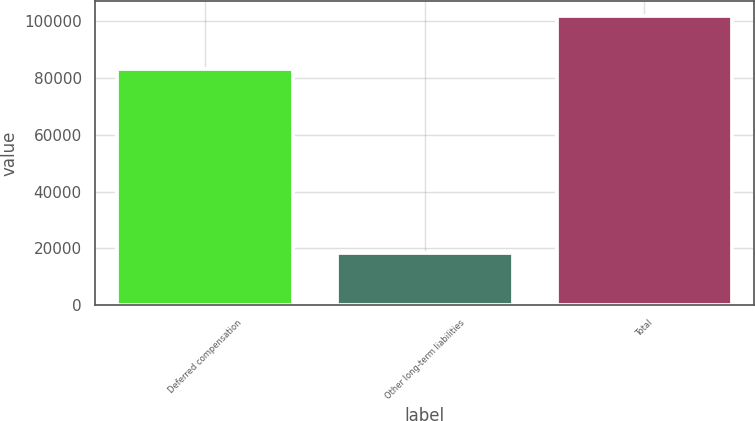Convert chart to OTSL. <chart><loc_0><loc_0><loc_500><loc_500><bar_chart><fcel>Deferred compensation<fcel>Other long-term liabilities<fcel>Total<nl><fcel>83330<fcel>18555<fcel>101885<nl></chart> 